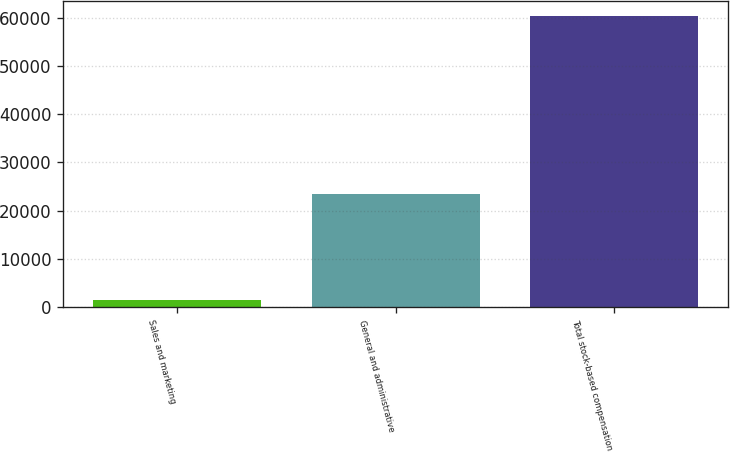<chart> <loc_0><loc_0><loc_500><loc_500><bar_chart><fcel>Sales and marketing<fcel>General and administrative<fcel>Total stock-based compensation<nl><fcel>1553<fcel>23452<fcel>60384<nl></chart> 